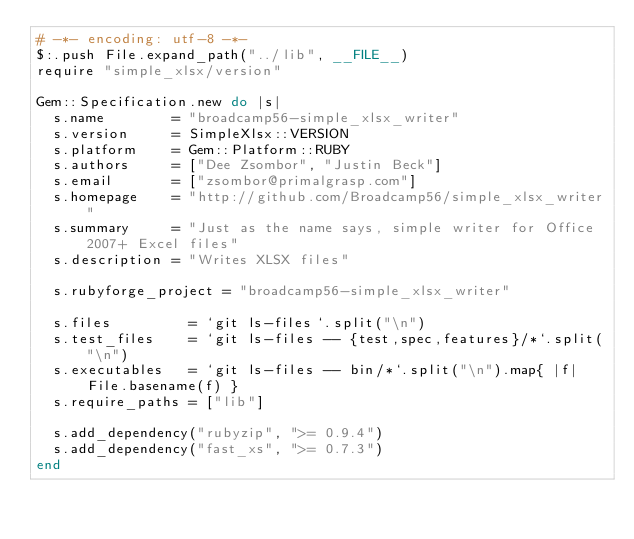<code> <loc_0><loc_0><loc_500><loc_500><_Ruby_># -*- encoding: utf-8 -*-
$:.push File.expand_path("../lib", __FILE__)
require "simple_xlsx/version"

Gem::Specification.new do |s|
  s.name        = "broadcamp56-simple_xlsx_writer"
  s.version     = SimpleXlsx::VERSION
  s.platform    = Gem::Platform::RUBY
  s.authors     = ["Dee Zsombor", "Justin Beck"]
  s.email       = ["zsombor@primalgrasp.com"]
  s.homepage    = "http://github.com/Broadcamp56/simple_xlsx_writer"
  s.summary     = "Just as the name says, simple writer for Office 2007+ Excel files"
  s.description = "Writes XLSX files"

  s.rubyforge_project = "broadcamp56-simple_xlsx_writer"

  s.files         = `git ls-files`.split("\n")
  s.test_files    = `git ls-files -- {test,spec,features}/*`.split("\n")
  s.executables   = `git ls-files -- bin/*`.split("\n").map{ |f| File.basename(f) }
  s.require_paths = ["lib"]

  s.add_dependency("rubyzip", ">= 0.9.4")
  s.add_dependency("fast_xs", ">= 0.7.3")
end
</code> 